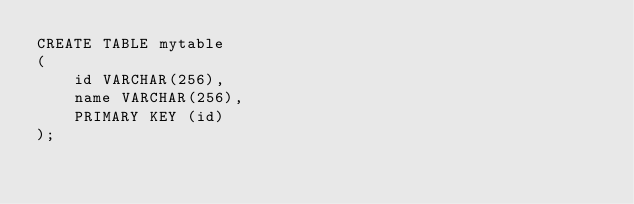<code> <loc_0><loc_0><loc_500><loc_500><_SQL_>CREATE TABLE mytable
(
    id VARCHAR(256),
    name VARCHAR(256),
    PRIMARY KEY (id)
);
</code> 